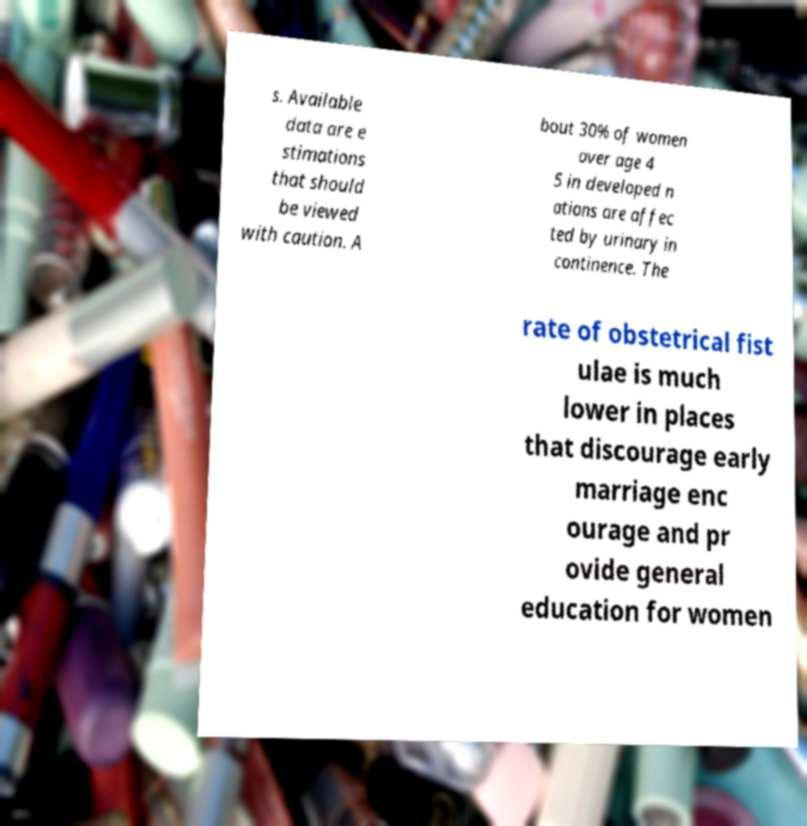Can you accurately transcribe the text from the provided image for me? s. Available data are e stimations that should be viewed with caution. A bout 30% of women over age 4 5 in developed n ations are affec ted by urinary in continence. The rate of obstetrical fist ulae is much lower in places that discourage early marriage enc ourage and pr ovide general education for women 